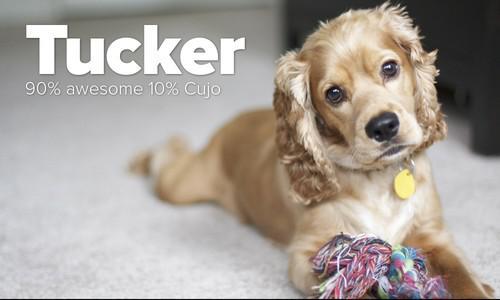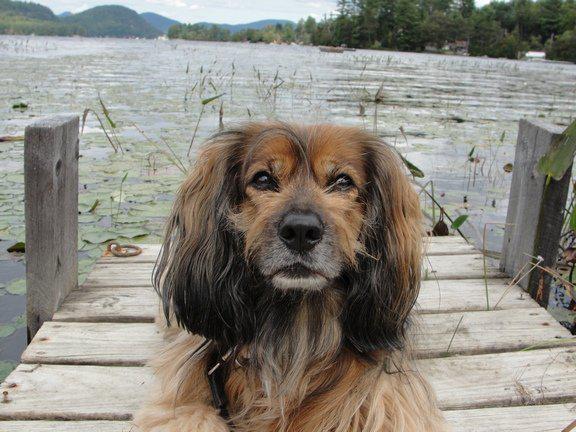The first image is the image on the left, the second image is the image on the right. Considering the images on both sides, is "The dog in the image on the left is outside." valid? Answer yes or no. No. The first image is the image on the left, the second image is the image on the right. Considering the images on both sides, is "One image shows a blonde spaniel with a metal tag on its collar and its head cocked to the left." valid? Answer yes or no. Yes. 